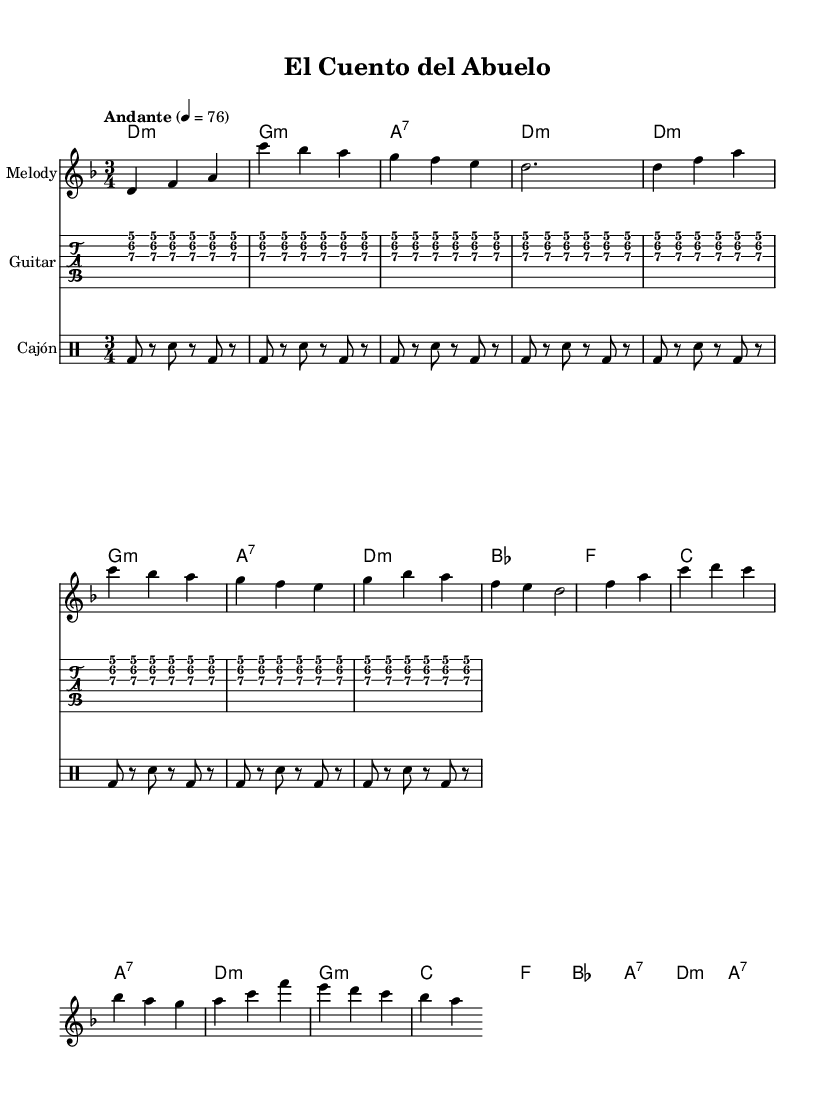What is the key signature of this music? The key signature is D minor, which has one flat (B flat).
Answer: D minor What is the time signature of this piece? The time signature is represented as 3/4, indicating three beats per measure.
Answer: 3/4 What is the tempo marking indicated in the score? The tempo marking is "Andante," which typically denotes a moderately slow pace.
Answer: Andante How many measures are in the introduction? The introduction consists of 4 measures as indicated by the notes and rests.
Answer: 4 What is the predominant harmony in the verse section? The harmonies in the verse section predominantly use D minor, G minor, and A7 chords.
Answer: D minor Which traditional Latin instrument is represented in the rhythm section? The rhythm section includes a cajón, a percussion instrument commonly used in Latin music.
Answer: Cajón What is the structure of the song based on the provided sections? The structure includes an Intro, Verse, and Chorus, following a narrative style typical in acoustic Latin folk music.
Answer: Intro, Verse, Chorus 